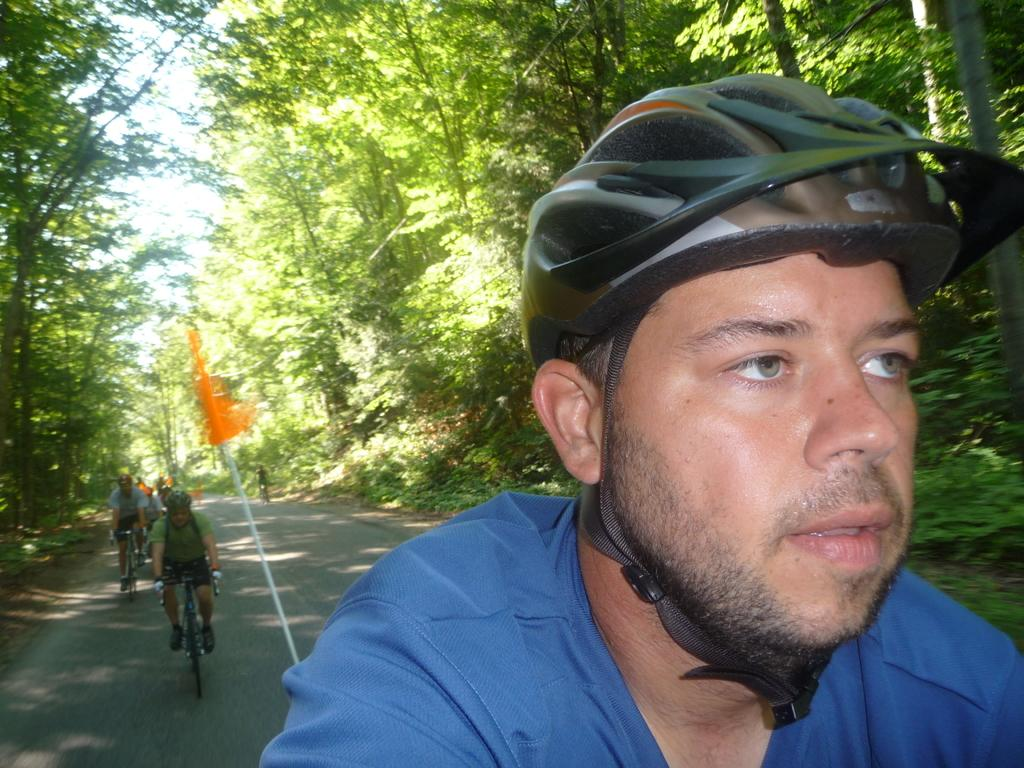What is the man in the image wearing on his head? The man in the image is wearing a helmet. What can be seen in the distance behind the people in the image? There are trees in the background of the image. What activity are the people engaged in? People are riding bicycles in the image. Can you see any mines in the image? No, there are no mines present in the image. Is the seashore visible in the image? No, the seashore is not visible in the image; there are trees in the background. 